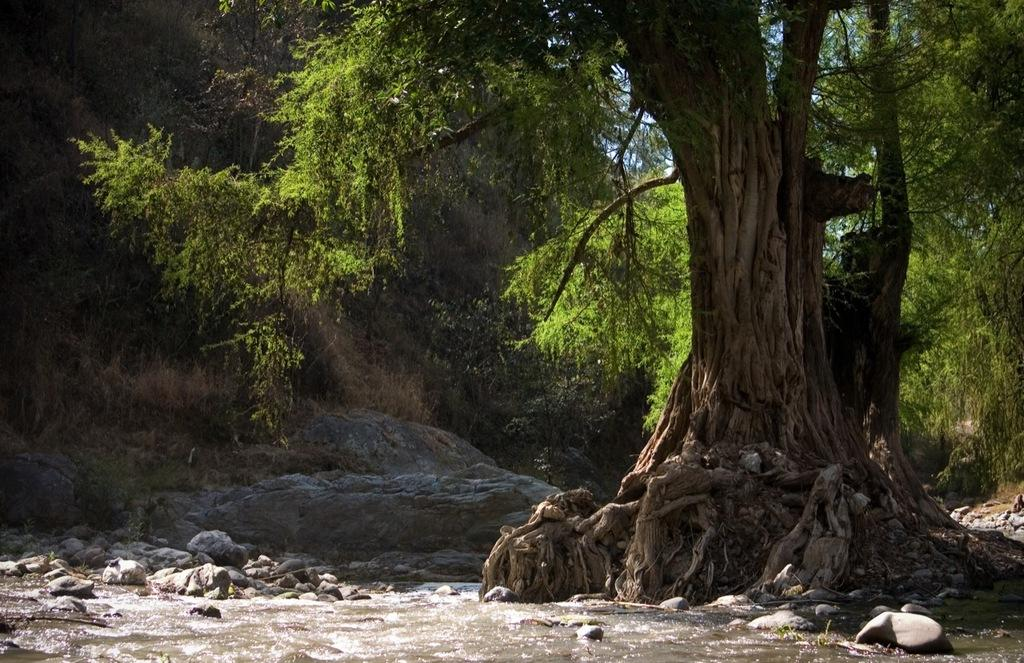What is the primary element visible in the image? There is water in the image. What other objects or features can be seen in the image? There are rocks in the image. What can be seen in the background of the image? There are trees and the sky visible in the background of the image. What type of sink can be seen in the image? There is no sink present in the image. What additional details can be observed about the trees in the background? The provided facts do not mention any specific details about the trees, so we cannot answer this question definitively. 